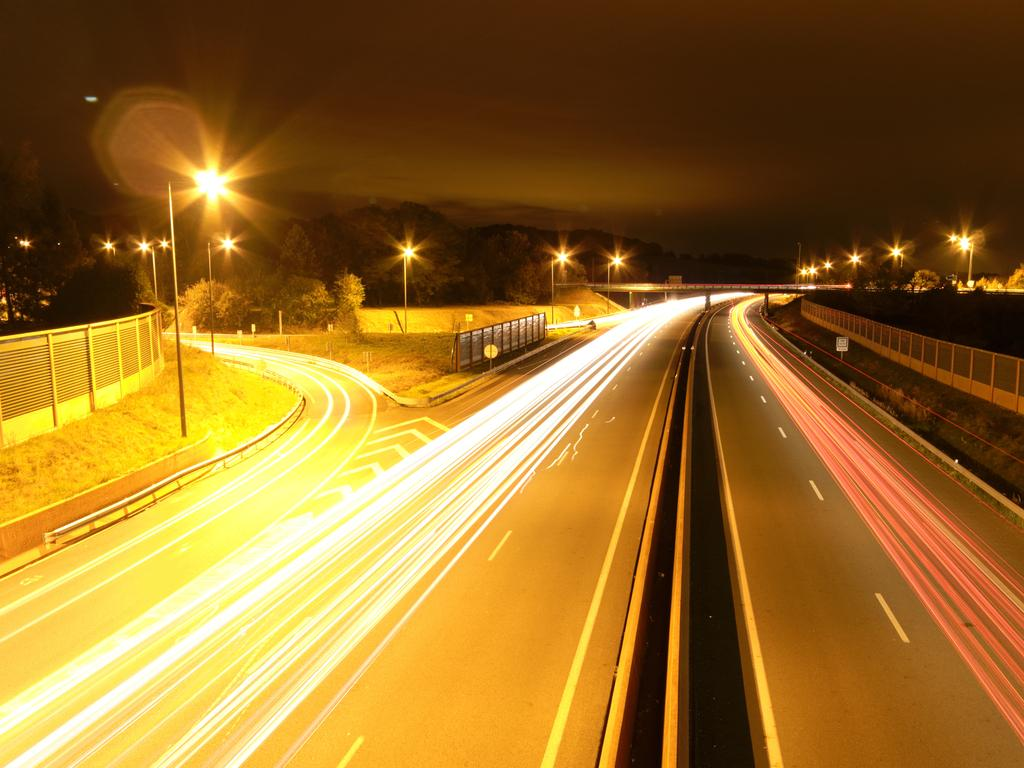What type of infrastructure can be seen in the image? There are roads in the image. What are the roads surrounded by? There are fences on the sides of the roads. What is used to illuminate the roads at night? Streetlights are present on the sides of the roads. What can be seen providing information or directions? There are sign boards in the image. What can be seen in the distance in the image? Trees are visible in the background of the image. How does the image depict the process of washing the can? There is no can present in the image, and no washing process is depicted. 